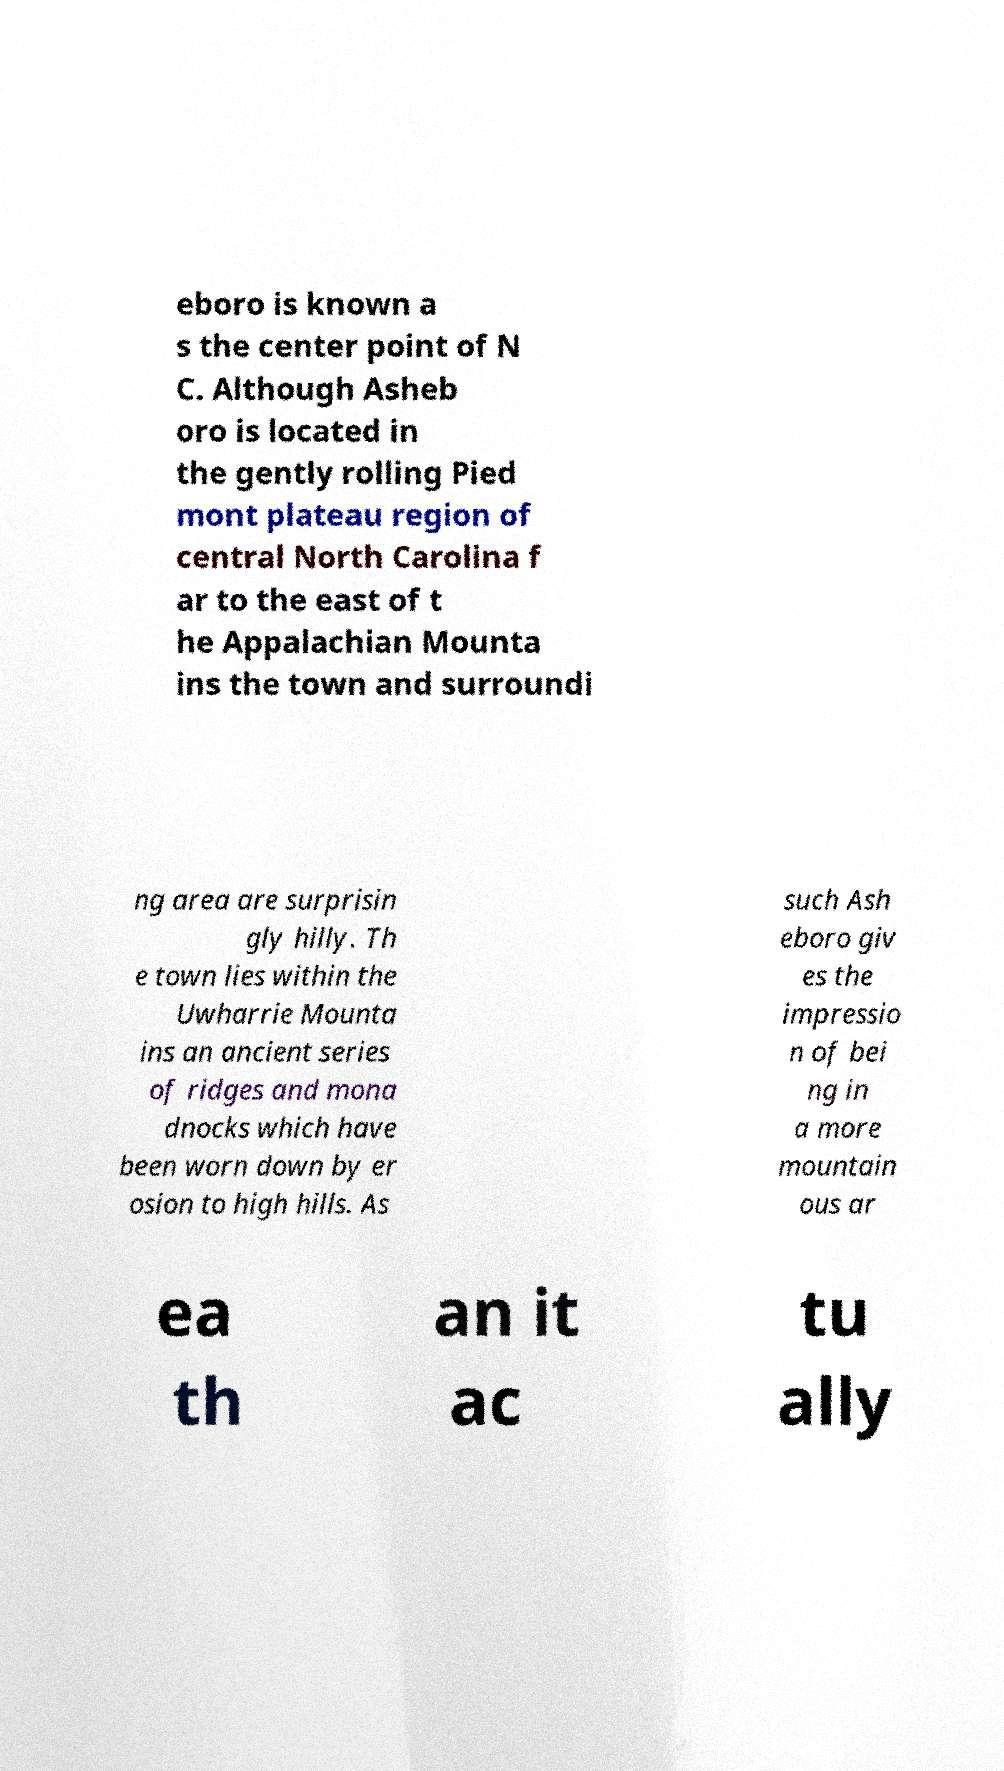What messages or text are displayed in this image? I need them in a readable, typed format. eboro is known a s the center point of N C. Although Asheb oro is located in the gently rolling Pied mont plateau region of central North Carolina f ar to the east of t he Appalachian Mounta ins the town and surroundi ng area are surprisin gly hilly. Th e town lies within the Uwharrie Mounta ins an ancient series of ridges and mona dnocks which have been worn down by er osion to high hills. As such Ash eboro giv es the impressio n of bei ng in a more mountain ous ar ea th an it ac tu ally 